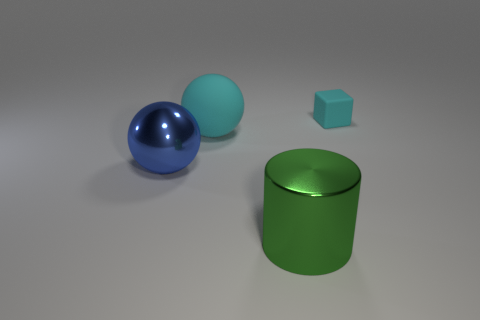Add 2 big spheres. How many objects exist? 6 Subtract all cyan cubes. How many cyan spheres are left? 1 Subtract all blocks. How many objects are left? 3 Subtract 1 spheres. How many spheres are left? 1 Subtract all yellow cubes. Subtract all blue spheres. How many cubes are left? 1 Subtract all cyan objects. Subtract all cyan cubes. How many objects are left? 1 Add 1 metal things. How many metal things are left? 3 Add 4 large matte spheres. How many large matte spheres exist? 5 Subtract 0 red balls. How many objects are left? 4 